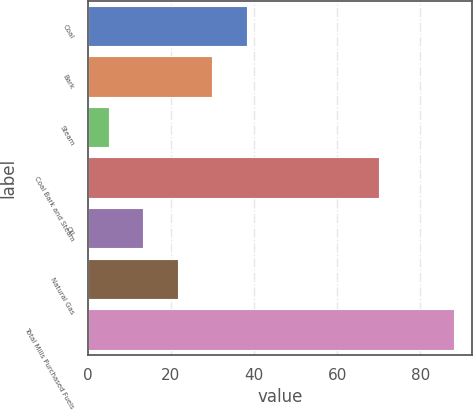Convert chart. <chart><loc_0><loc_0><loc_500><loc_500><bar_chart><fcel>Coal<fcel>Bark<fcel>Steam<fcel>Coal Bark and Steam<fcel>Oil<fcel>Natural Gas<fcel>Total Mills Purchased Fuels<nl><fcel>38.2<fcel>29.9<fcel>5<fcel>70<fcel>13.3<fcel>21.6<fcel>88<nl></chart> 